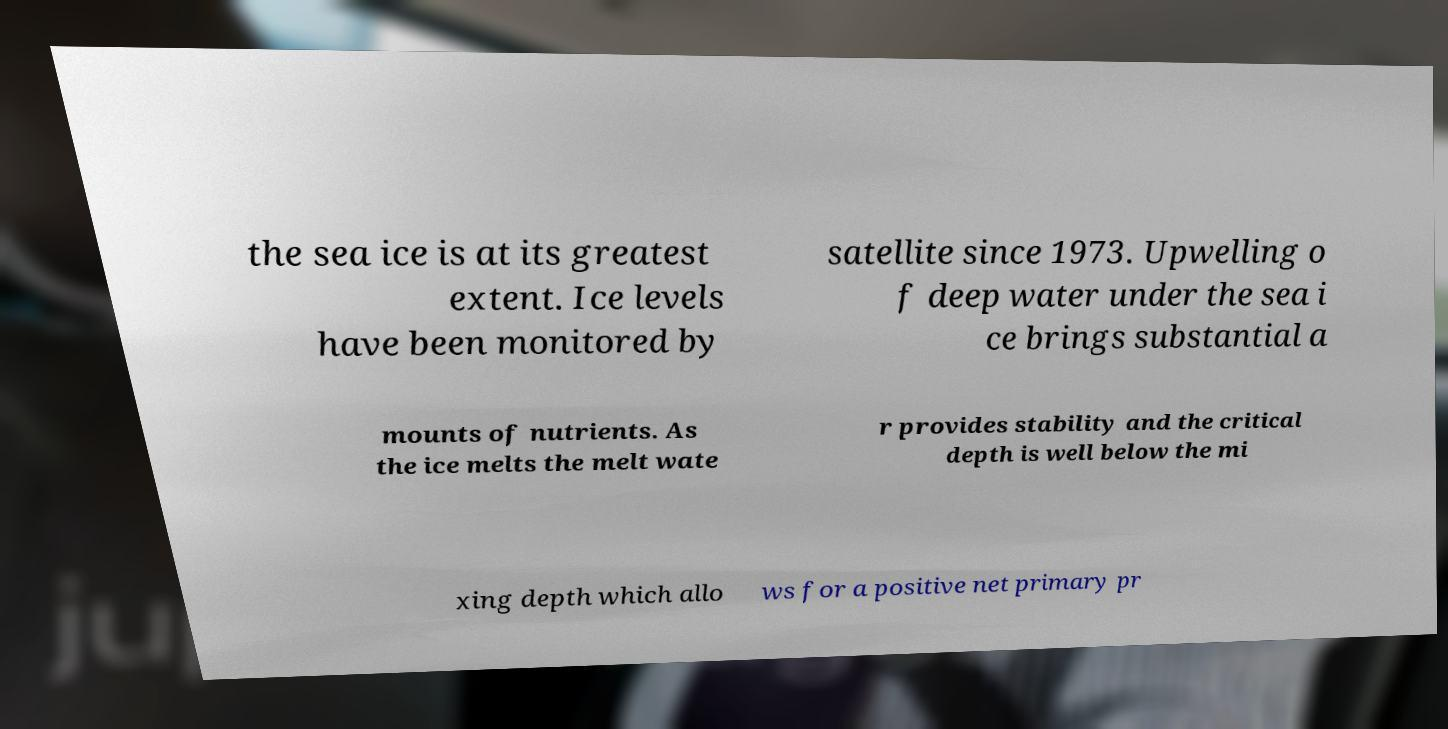What messages or text are displayed in this image? I need them in a readable, typed format. the sea ice is at its greatest extent. Ice levels have been monitored by satellite since 1973. Upwelling o f deep water under the sea i ce brings substantial a mounts of nutrients. As the ice melts the melt wate r provides stability and the critical depth is well below the mi xing depth which allo ws for a positive net primary pr 